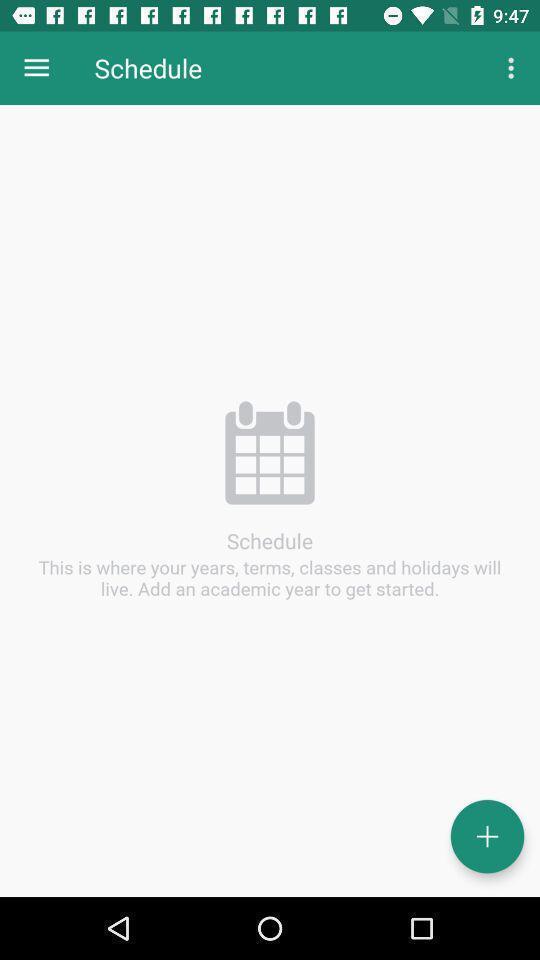Please provide a description for this image. Screen showing schedule with add option. 